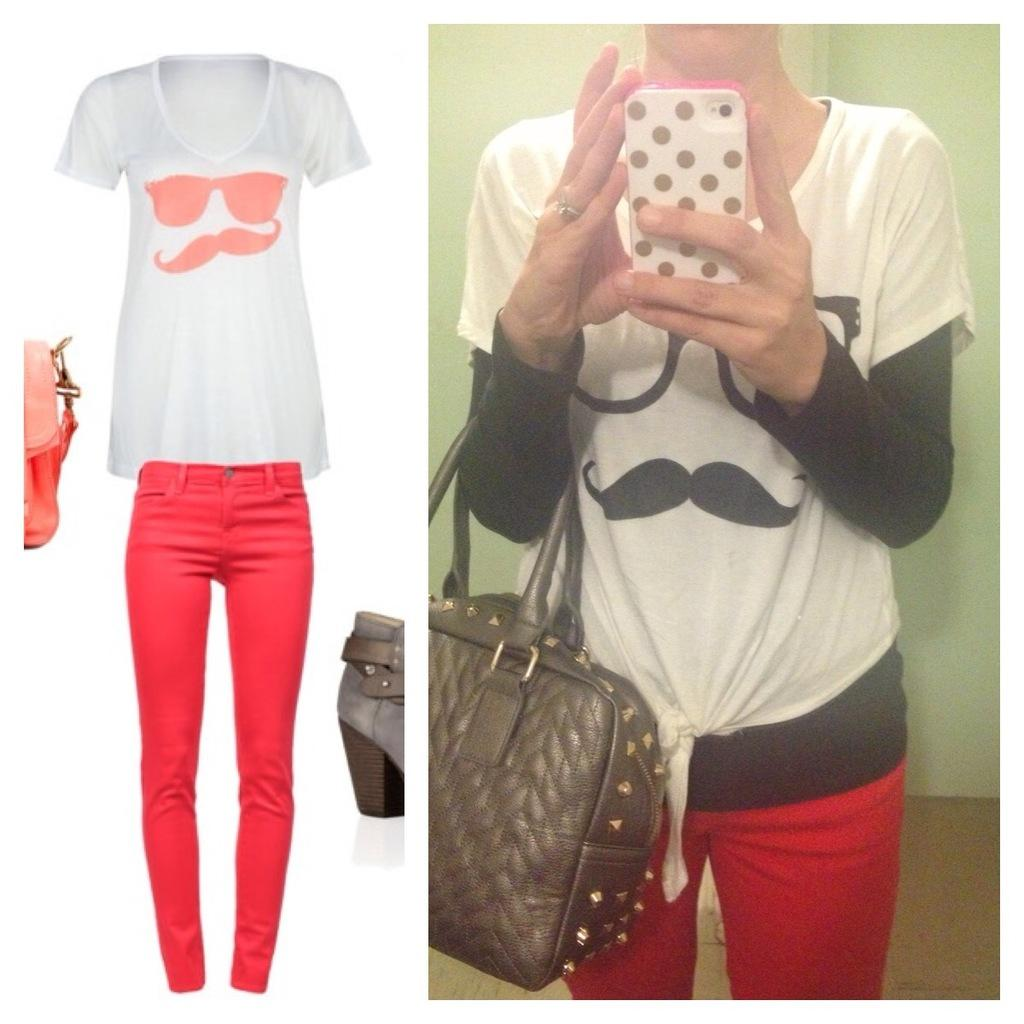What can be seen in the image? There is a person in the image. What is the person wearing? The person is wearing a handbag. What is the person holding? The person is holding a mobile phone. What type of clothing is depicted in the image? There are images of a t-shirt and pants in the image. What type of pizzas are being served at the meeting in the image? There is no meeting or pizzas present in the image. 